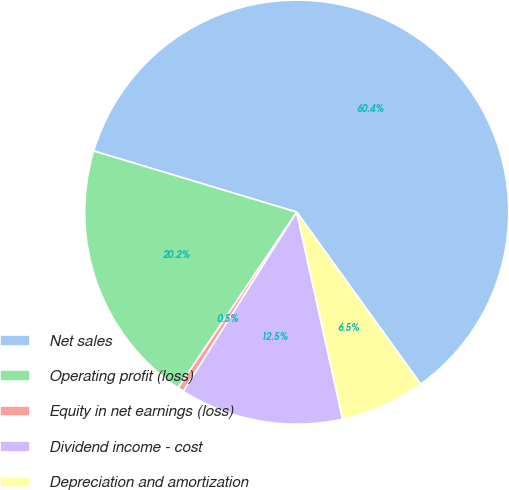Convert chart to OTSL. <chart><loc_0><loc_0><loc_500><loc_500><pie_chart><fcel>Net sales<fcel>Operating profit (loss)<fcel>Equity in net earnings (loss)<fcel>Dividend income - cost<fcel>Depreciation and amortization<nl><fcel>60.41%<fcel>20.21%<fcel>0.47%<fcel>12.46%<fcel>6.46%<nl></chart> 